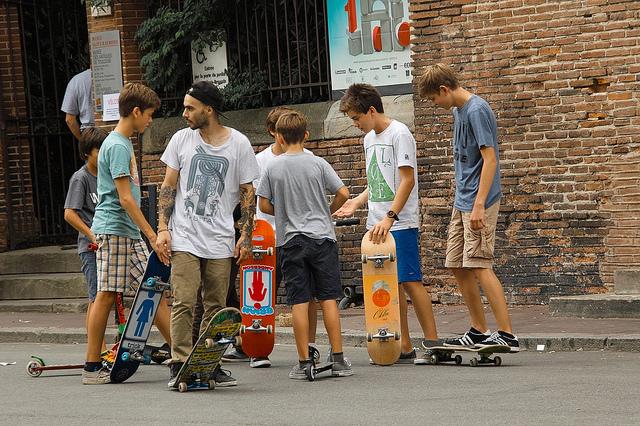What are the boys holding?
Keep it brief. Skateboards. What type of shoes are the boys wearing?
Be succinct. Tennis shoes. What are the boys doing?
Short answer required. Skateboarding. 